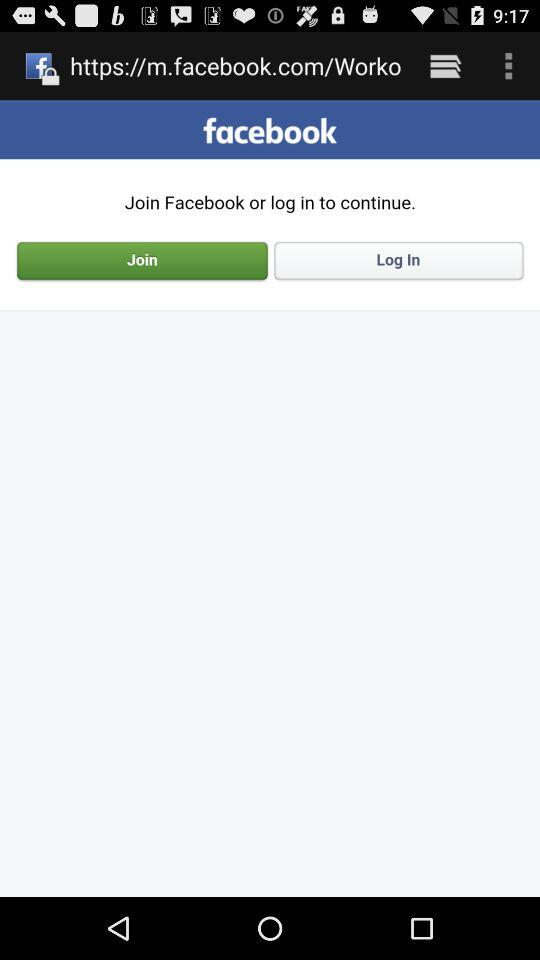What is the name of the application? The name of the application is "facebook". 